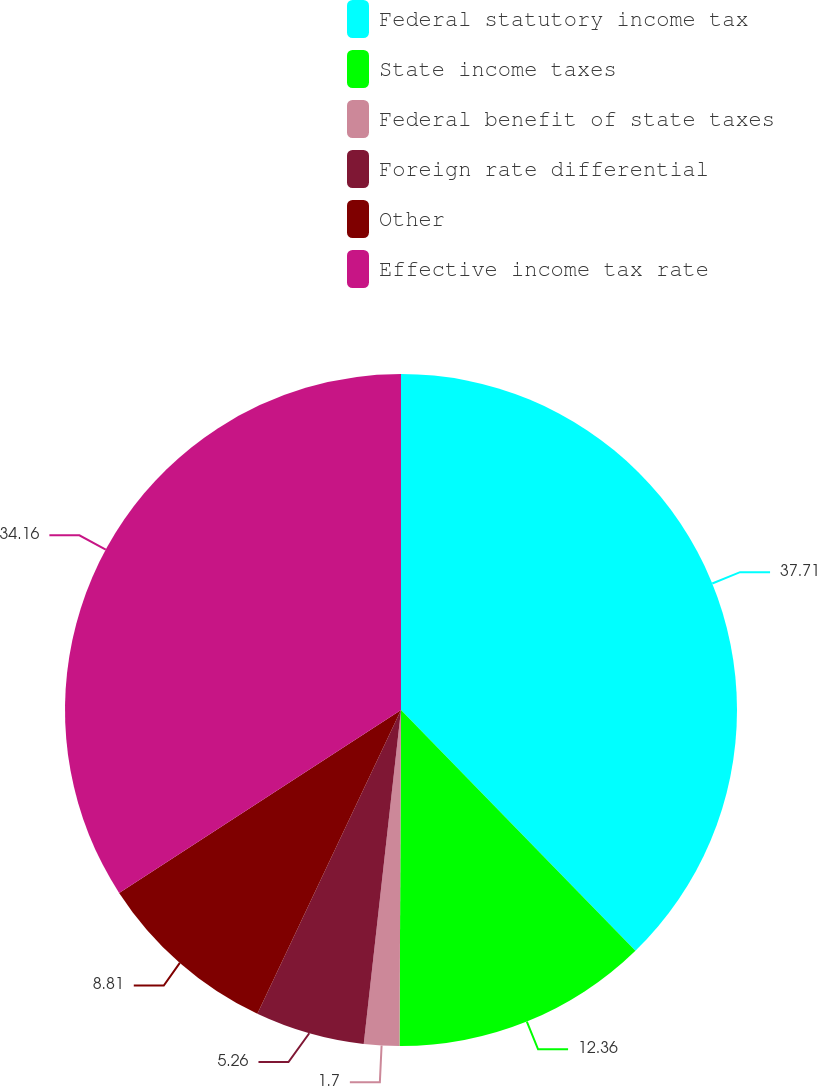<chart> <loc_0><loc_0><loc_500><loc_500><pie_chart><fcel>Federal statutory income tax<fcel>State income taxes<fcel>Federal benefit of state taxes<fcel>Foreign rate differential<fcel>Other<fcel>Effective income tax rate<nl><fcel>37.71%<fcel>12.36%<fcel>1.7%<fcel>5.26%<fcel>8.81%<fcel>34.16%<nl></chart> 